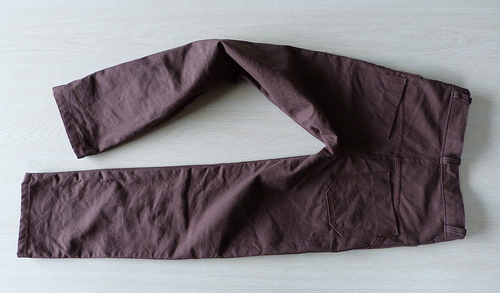<image>
Can you confirm if the white pants is on the brown surface? No. The white pants is not positioned on the brown surface. They may be near each other, but the white pants is not supported by or resting on top of the brown surface. 